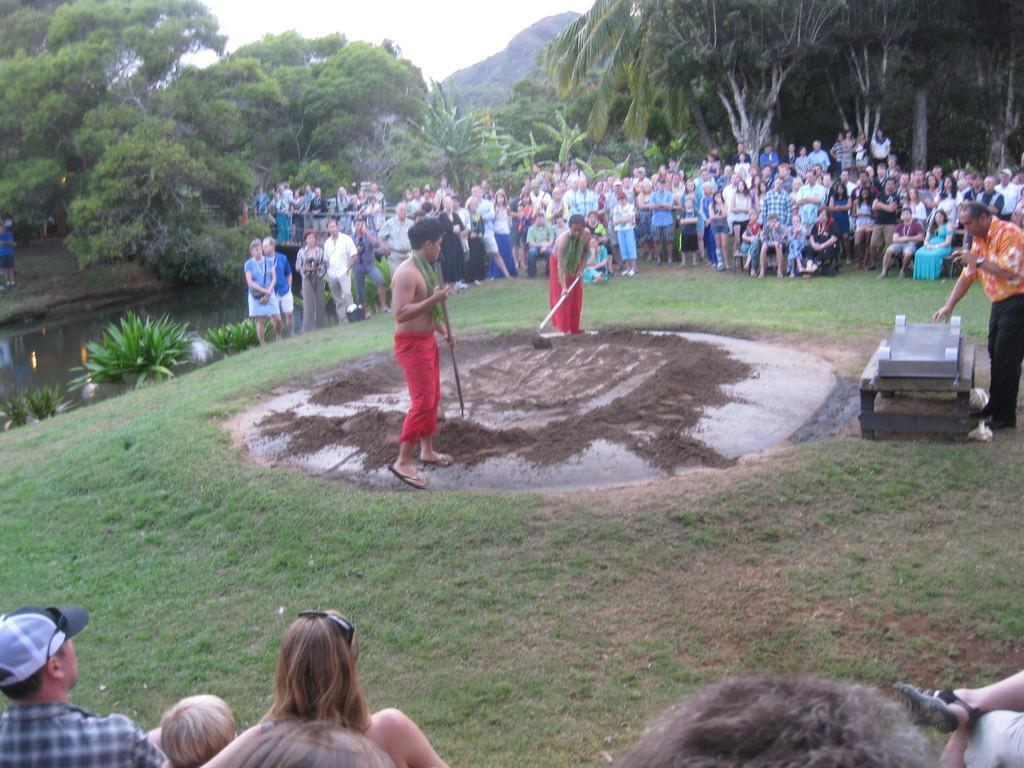In one or two sentences, can you explain what this image depicts? In this image we can see the mountains, some people are sitting on the benches, some people are standing, one bridge, one canal, some objects on the ground, some people are holding some objects, two people digging in the ground, some trees, bushes, plants and grass on the ground. At the top there is the sky. 